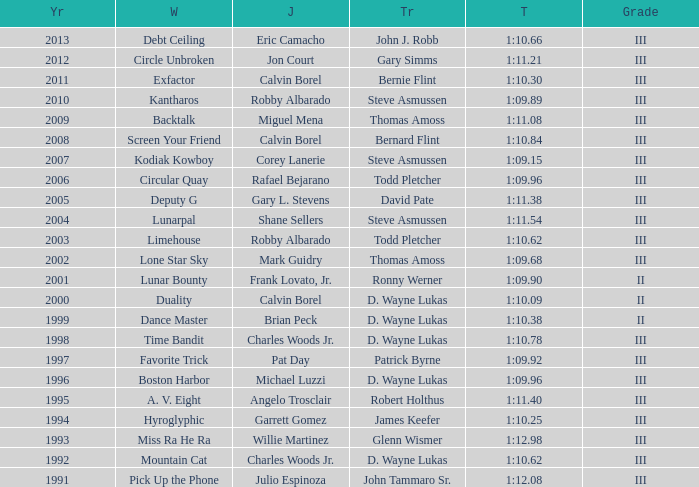What was the time for Screen Your Friend? 1:10.84. 